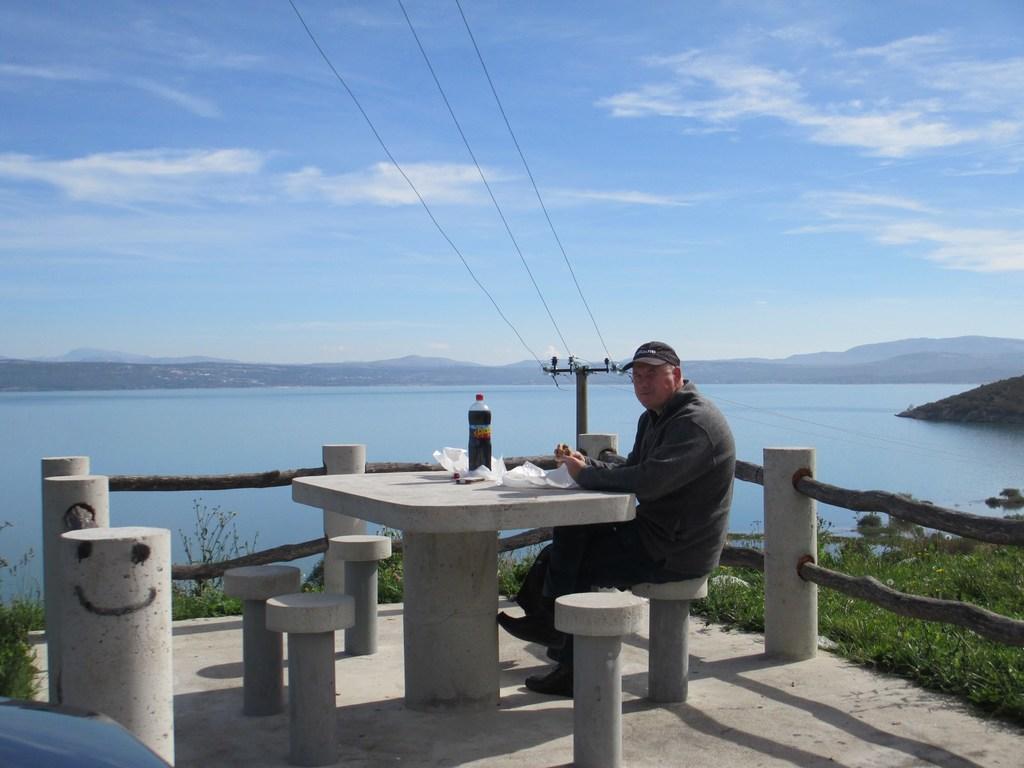Can you describe this image briefly? In this picture I can see a man sitting and I can see a bottle, few papers on the table and I can see water, few plants, a pole and a blue cloudy sky. 